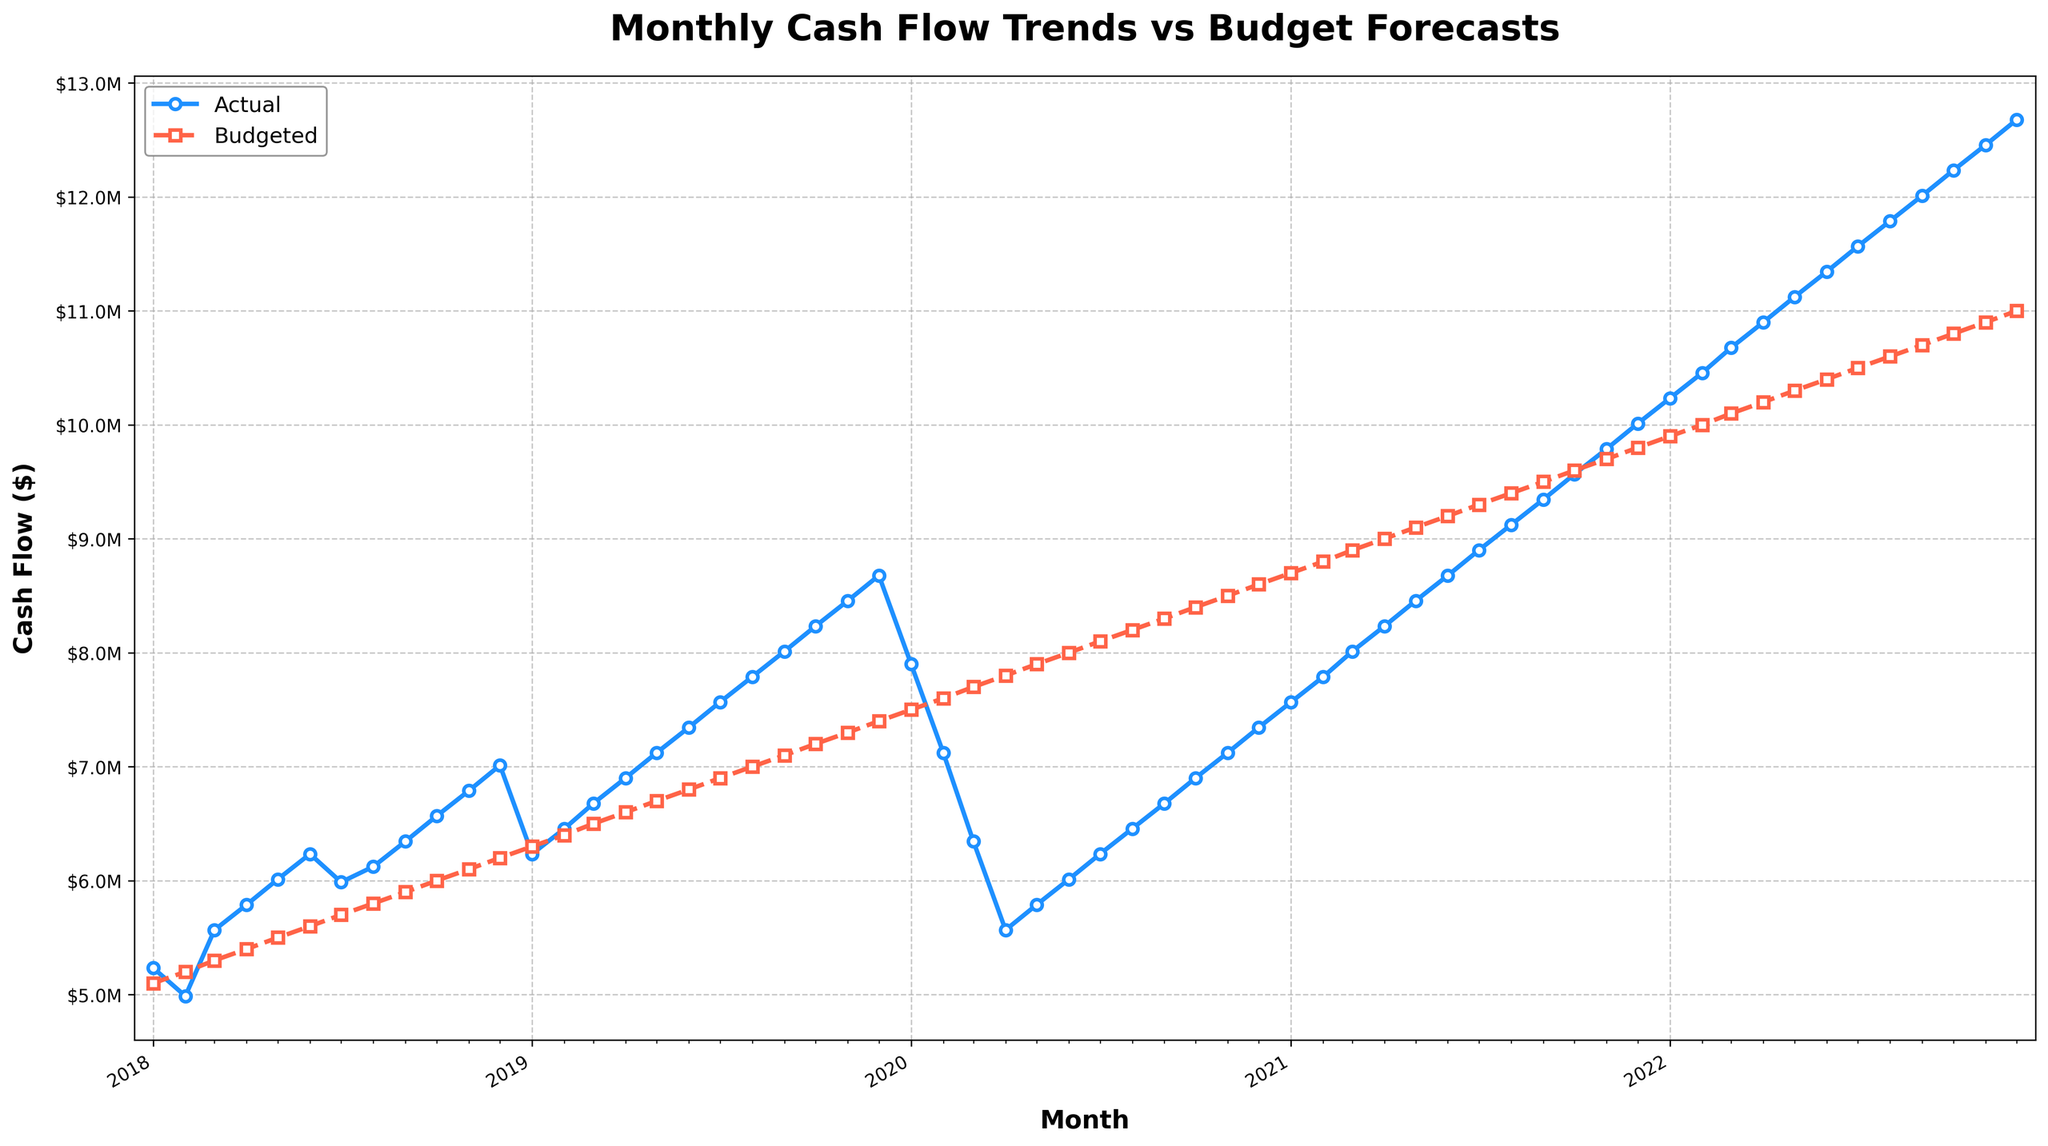What's the overall trend of the Actual Cash Flow over the last 5 years? The Actual Cash Flow consistently increases each year. Starting from around $5.2M in early 2018, it rises continuously and reaches approximately $12.6M by the end of 2022.
Answer: Increasing trend How does the Actual Cash Flow in December 2019 compare to the Budgeted Cash Flow in December 2019? In December 2019, the Actual Cash Flow is displayed as a blue marker, and the Budgeted Cash Flow as a red marker. The Actual Cash Flow is significantly higher at $8.68M compared to the Budgeted Cash Flow at $7.4M.
Answer: Higher What was the highest Actual Cash Flow between January 2018 and December 2022? Examine the peaks of the blue line across the timeline. The highest Actual Cash Flow occurs at the end of the figure in December 2022, reaching approximately $12.68M.
Answer: December 2022 Which month and year showed the largest gap between the Actual and Budgeted Cash Flow? Compare the vertical distance between the blue and red lines across the years. October 2022 has the largest gap with the Actual Cash Flow at $12.2M and Budgeted Cash Flow at $10.8M, resulting in a gap of $1.4M.
Answer: October 2022 Was there ever a time when the Actual Cash Flow was lower than the Budgeted Cash Flow? If so, when? Observe the cross points or areas where the blue line dips below the red line. This occurs in early 2020, where the Actual Cash Flow is lower than Budgeted Cash Flow from January to July.
Answer: Yes, from January to July 2020 What's the average Actual Cash Flow in 2020? Identify and sum all Actual Cash Flow values from January to December 2020 ($7.9M + $7.1M + $6.3M + $5.6M + $5.8M + $6.0M + $6.2M + $6.4M + $6.7M + $6.9M + $7.1M + $7.3M), then divide by 12. This equals to $75.3M divided by 12.
Answer: Approximately $6.275M How did the Actual Cash Flow change from January 2019 to January 2020? Look at the blue line in January 2019 and January 2020. In January 2019, it was about $6.23M and rose to approximately $7.9M in January 2020, indicating an increase.
Answer: Increased Compare the trend of Budgeted Cash Flow from 2018 to 2022. Observe the red dashed line from 2018 to 2022. It shows a consistent increase, beginning at around $5.1M in January 2018 and reaching $11M in December 2022.
Answer: Increasing trend During which period did the Actual Cash Flow fall below the Budgeted Cash Flow in 2020? Observe the 2020 section where the blue (Actual) line dips below the red (Budgeted) line. This happens from January 2020 until about July 2020.
Answer: January to July What month showed a significant increase in Actual Cash Flow compared to the previous month? Look for sharp upward slopes in the blue line. A significant increase is observed from February 2019 ($6.45M) to March 2019 ($6.67M).
Answer: March 2019 